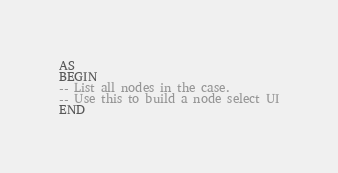<code> <loc_0><loc_0><loc_500><loc_500><_SQL_>AS 
BEGIN
-- List all nodes in the case.  
-- Use this to build a node select UI
END
</code> 